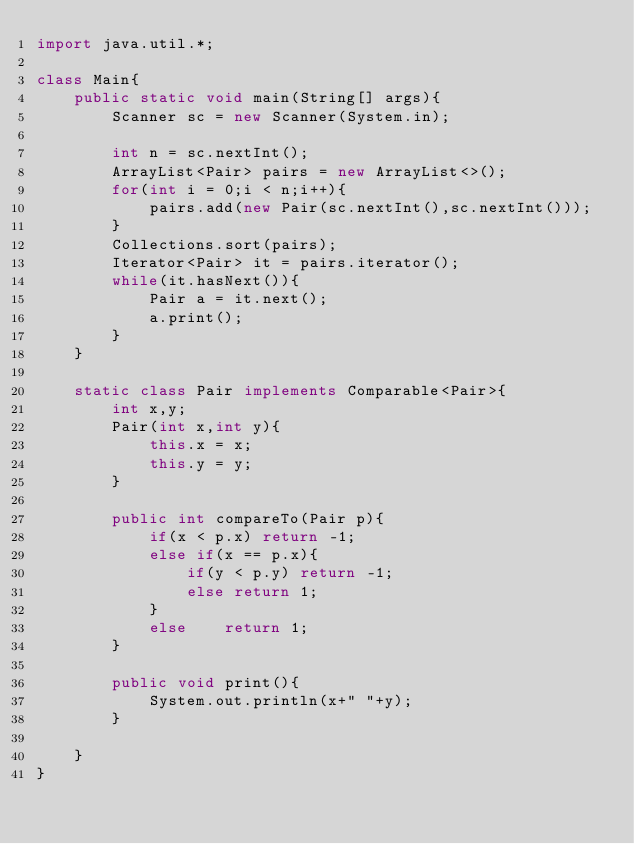<code> <loc_0><loc_0><loc_500><loc_500><_Java_>import java.util.*;

class Main{
    public static void main(String[] args){
        Scanner sc = new Scanner(System.in);

        int n = sc.nextInt();
        ArrayList<Pair> pairs = new ArrayList<>();
        for(int i = 0;i < n;i++){
            pairs.add(new Pair(sc.nextInt(),sc.nextInt()));
        }
        Collections.sort(pairs);
        Iterator<Pair> it = pairs.iterator();
        while(it.hasNext()){
            Pair a = it.next();
            a.print();
        }
    }

    static class Pair implements Comparable<Pair>{
        int x,y;
        Pair(int x,int y){
            this.x = x;
            this.y = y;
        }

        public int compareTo(Pair p){
            if(x < p.x) return -1;
            else if(x == p.x){
                if(y < p.y) return -1;
                else return 1;
            }
            else    return 1;
        }

        public void print(){
            System.out.println(x+" "+y);
        }
        
    }
}
</code> 